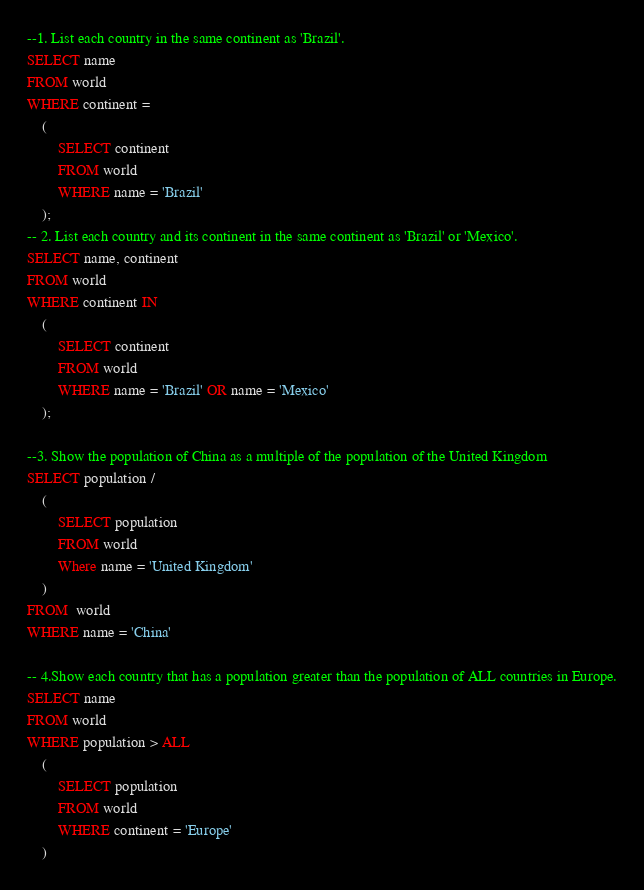Convert code to text. <code><loc_0><loc_0><loc_500><loc_500><_SQL_>--1. List each country in the same continent as 'Brazil'.
SELECT name 
FROM world 
WHERE continent = 
	(	
		SELECT continent
		FROM world
		WHERE name = 'Brazil'
	);
-- 2. List each country and its continent in the same continent as 'Brazil' or 'Mexico'.
SELECT name, continent
FROM world
WHERE continent IN
	(
		SELECT continent
		FROM world
		WHERE name = 'Brazil' OR name = 'Mexico'
	);
	
--3. Show the population of China as a multiple of the population of the United Kingdom
SELECT population / 
	(
		SELECT population
		FROM world
		Where name = 'United Kingdom'
	)
FROM  world
WHERE name = 'China'

-- 4.Show each country that has a population greater than the population of ALL countries in Europe.
SELECT name 
FROM world
WHERE population > ALL
	(
		SELECT population
		FROM world
		WHERE continent = 'Europe'
	)</code> 